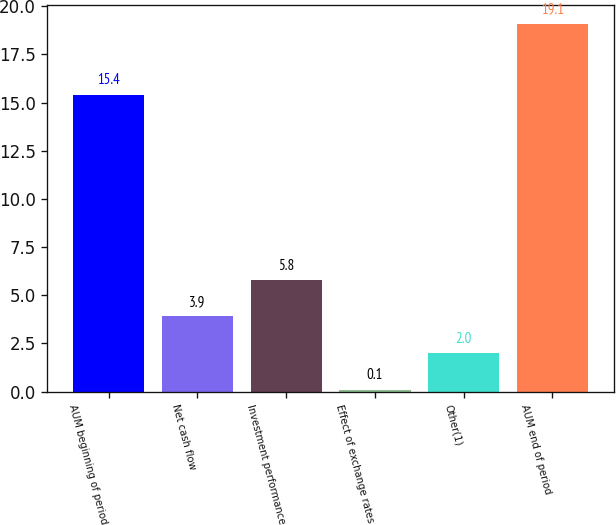Convert chart. <chart><loc_0><loc_0><loc_500><loc_500><bar_chart><fcel>AUM beginning of period<fcel>Net cash flow<fcel>Investment performance<fcel>Effect of exchange rates<fcel>Other(1)<fcel>AUM end of period<nl><fcel>15.4<fcel>3.9<fcel>5.8<fcel>0.1<fcel>2<fcel>19.1<nl></chart> 